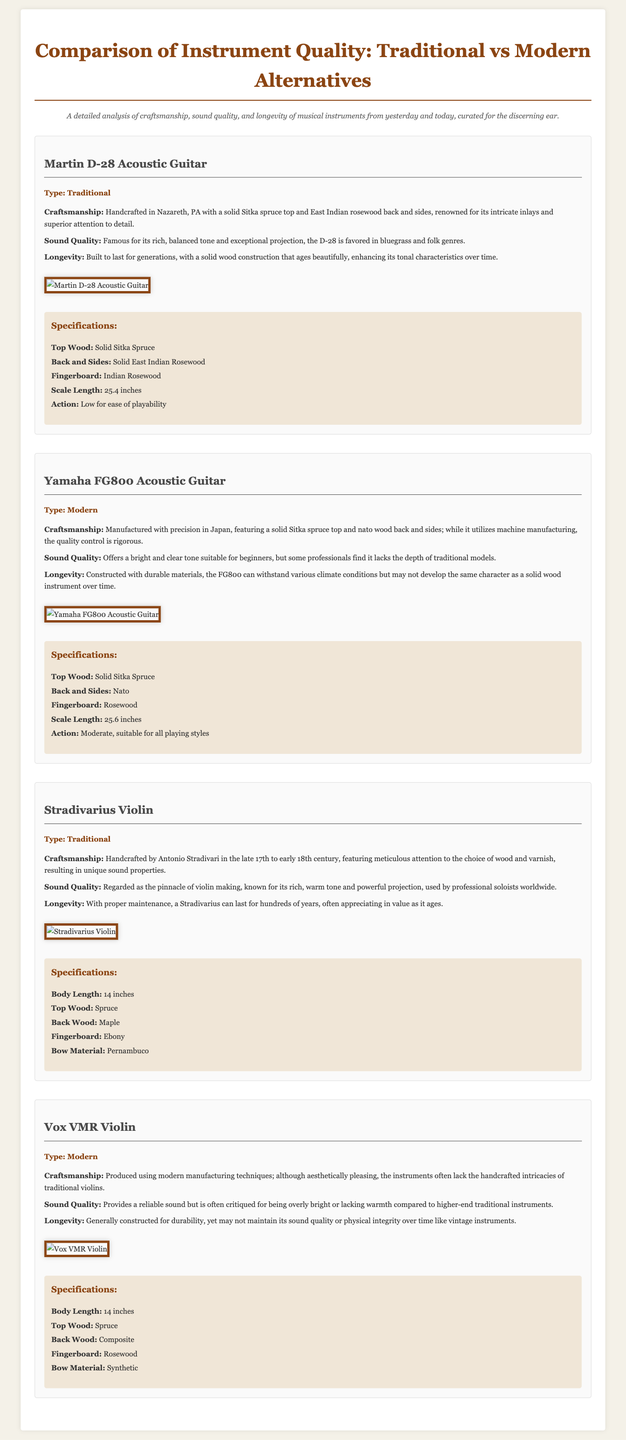what is the type of the Martin D-28 acoustic guitar? The type of the Martin D-28 acoustic guitar is labeled in the document as "Traditional."
Answer: Traditional where is the Martin D-28 handcrafted? The document specifies that the Martin D-28 is handcrafted in Nazareth, PA.
Answer: Nazareth, PA what wood is used for the back and sides of the Yamaha FG800? The document indicates that the back and sides of the Yamaha FG800 are made of Nato wood.
Answer: Nato what is the scale length of the Stradivarius violin? The scale length is provided in the specifications as 14 inches.
Answer: 14 inches which instrument is known for its rich, warm tone? The Stradivarius violin is specifically noted for its rich, warm tone in the document.
Answer: Stradivarius compare the craftsmanship of the Vox VMR violin with the Stradivarius violin. The Vox VMR violin is produced using modern manufacturing techniques, while the Stradivarius violin is handcrafted with meticulous attention to detail.
Answer: Modern vs. Handcrafted which guitar model is favored in bluegrass and folk genres? The document states that the Martin D-28 acoustic guitar is favored in bluegrass and folk genres.
Answer: Martin D-28 what is the bow material of the Vox VMR violin? The bow material for the Vox VMR violin is specified as Synthetic in the document.
Answer: Synthetic how long can a Stradivarius violin last with proper maintenance? The document mentions that a Stradivarius violin can last for hundreds of years with proper maintenance.
Answer: Hundreds of years 